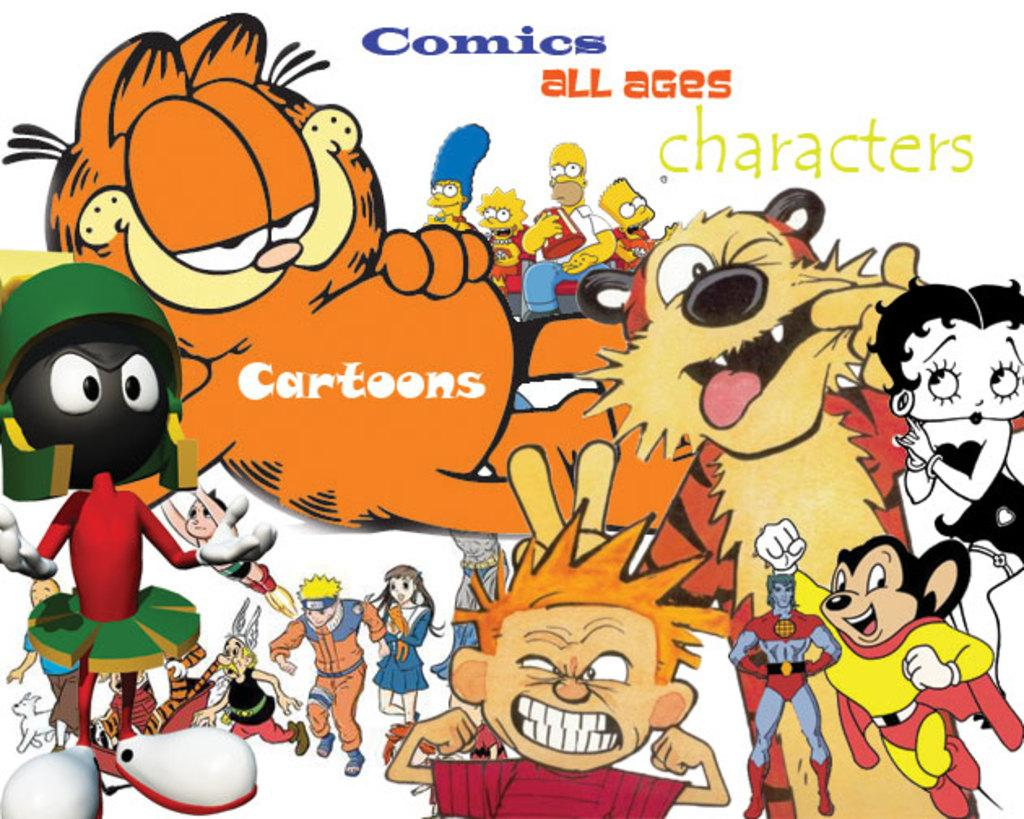What type of characters can be seen in the image? There are comic characters in the image. What type of sign can be seen in the image? There is no sign present in the image; it only features comic characters. How many snakes are visible in the image? There are no snakes present in the image; it only features comic characters. 